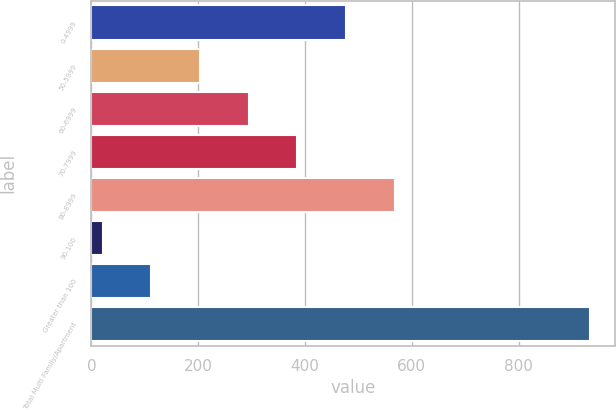Convert chart. <chart><loc_0><loc_0><loc_500><loc_500><bar_chart><fcel>0-4999<fcel>50-5999<fcel>60-6999<fcel>70-7999<fcel>80-8999<fcel>90-100<fcel>Greater than 100<fcel>Total Multi Family/Apartment<nl><fcel>477<fcel>203.4<fcel>294.6<fcel>385.8<fcel>568.2<fcel>21<fcel>112.2<fcel>933<nl></chart> 